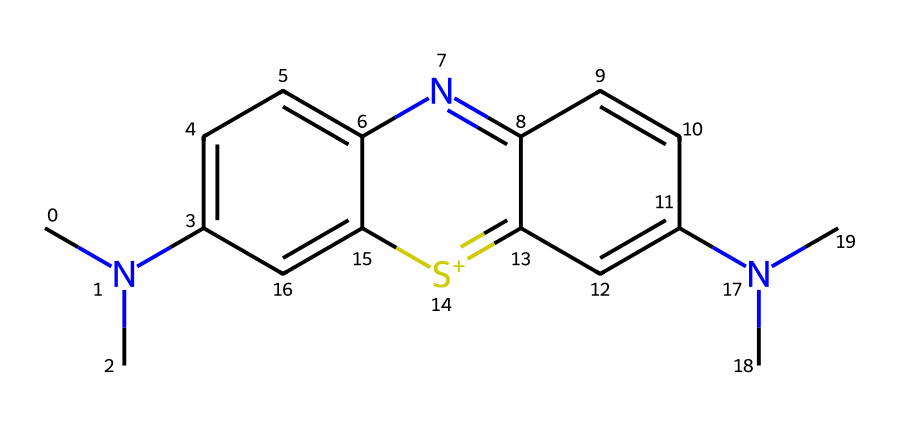What is the name of this chemical? The chemical structure provided corresponds to a well-known synthetic dye commonly used in microscopy. This specific structure represents methylene blue, recognized for its vivid color and application in biological staining.
Answer: methylene blue How many nitrogen atoms are in the structure? Observing the SMILES representation, we can identify the nitrogen atoms labeled by 'N'. In total, there are three nitrogen atoms present in the structure.
Answer: three How many carbon atoms are present in this dye? By counting the carbon atoms in the SMILES notation, we can identify the presence of carbon atoms represented by the letter 'C'. The structure includes a total of 15 carbon atoms.
Answer: fifteen What type of ion is indicated in the structure? In the SMILES representation, the '[s+]' indicates a positively charged sulfur ion, which is characteristic of many dyes that contain sulfur. This is an important feature of methylene blue.
Answer: positively charged sulfur Does this compound have any aromatic rings? Analyzing the structure, the presence of alternating double bonds in particular regions indicates the existence of aromatic rings. In fact, there are multiple aromatic rings in the structure of methylene blue, which enhances its stability and color properties.
Answer: multiple What functional groups are present in methylene blue? By examining the SMILES structure, we can identify the presence of tertiary amines (indicated by the 'N(C)' segments) and nitrogen-containing heterocycles that contribute to its dye functionality. These functional groups are essential for its staining properties.
Answer: tertiary amines and heterocycles 